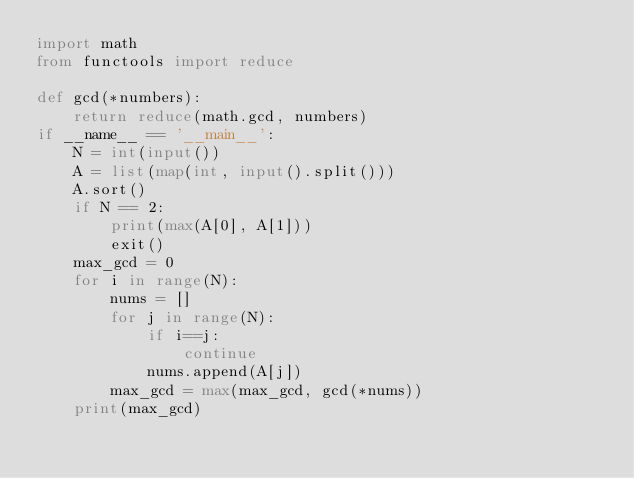Convert code to text. <code><loc_0><loc_0><loc_500><loc_500><_Python_>import math
from functools import reduce

def gcd(*numbers):
    return reduce(math.gcd, numbers)
if __name__ == '__main__':
    N = int(input())
    A = list(map(int, input().split()))
    A.sort()
    if N == 2:
        print(max(A[0], A[1]))
        exit()
    max_gcd = 0
    for i in range(N):
        nums = []
        for j in range(N):
            if i==j:
                continue 
            nums.append(A[j])
        max_gcd = max(max_gcd, gcd(*nums))
    print(max_gcd)</code> 